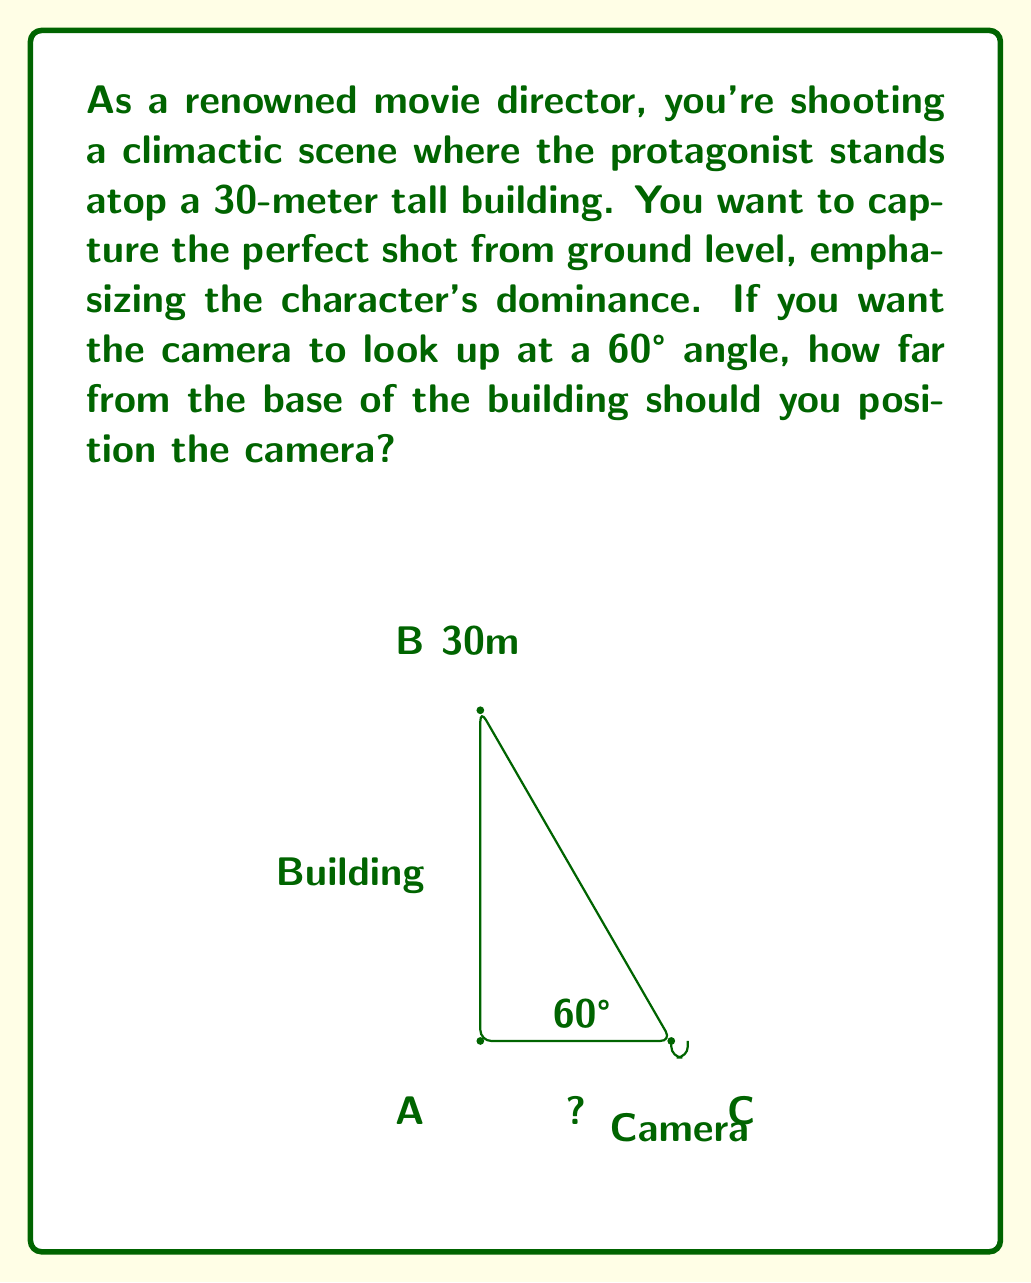Teach me how to tackle this problem. Let's approach this step-by-step using trigonometry:

1) We can model this scenario as a right triangle, where:
   - The building height is the opposite side (30 meters)
   - The distance from the building to the camera is the adjacent side (what we're solving for)
   - The angle from the ground to the camera's line of sight is 60°

2) In a right triangle, the tangent of an angle is the ratio of the opposite side to the adjacent side:

   $$\tan \theta = \frac{\text{opposite}}{\text{adjacent}}$$

3) We know $\theta = 60°$ and the opposite side (building height) is 30 meters. Let's call the adjacent side (distance we're solving for) $x$. We can write:

   $$\tan 60° = \frac{30}{x}$$

4) We know that $\tan 60° = \sqrt{3}$, so we can rewrite our equation:

   $$\sqrt{3} = \frac{30}{x}$$

5) To solve for $x$, we multiply both sides by $x$:

   $$x\sqrt{3} = 30$$

6) Then divide both sides by $\sqrt{3}$:

   $$x = \frac{30}{\sqrt{3}} = \frac{30}{\sqrt{3}} \cdot \frac{\sqrt{3}}{\sqrt{3}} = \frac{30\sqrt{3}}{3} = 10\sqrt{3}$$

7) Therefore, the distance from the base of the building to the camera should be $10\sqrt{3}$ meters, or approximately 17.32 meters.
Answer: $10\sqrt{3}$ meters 